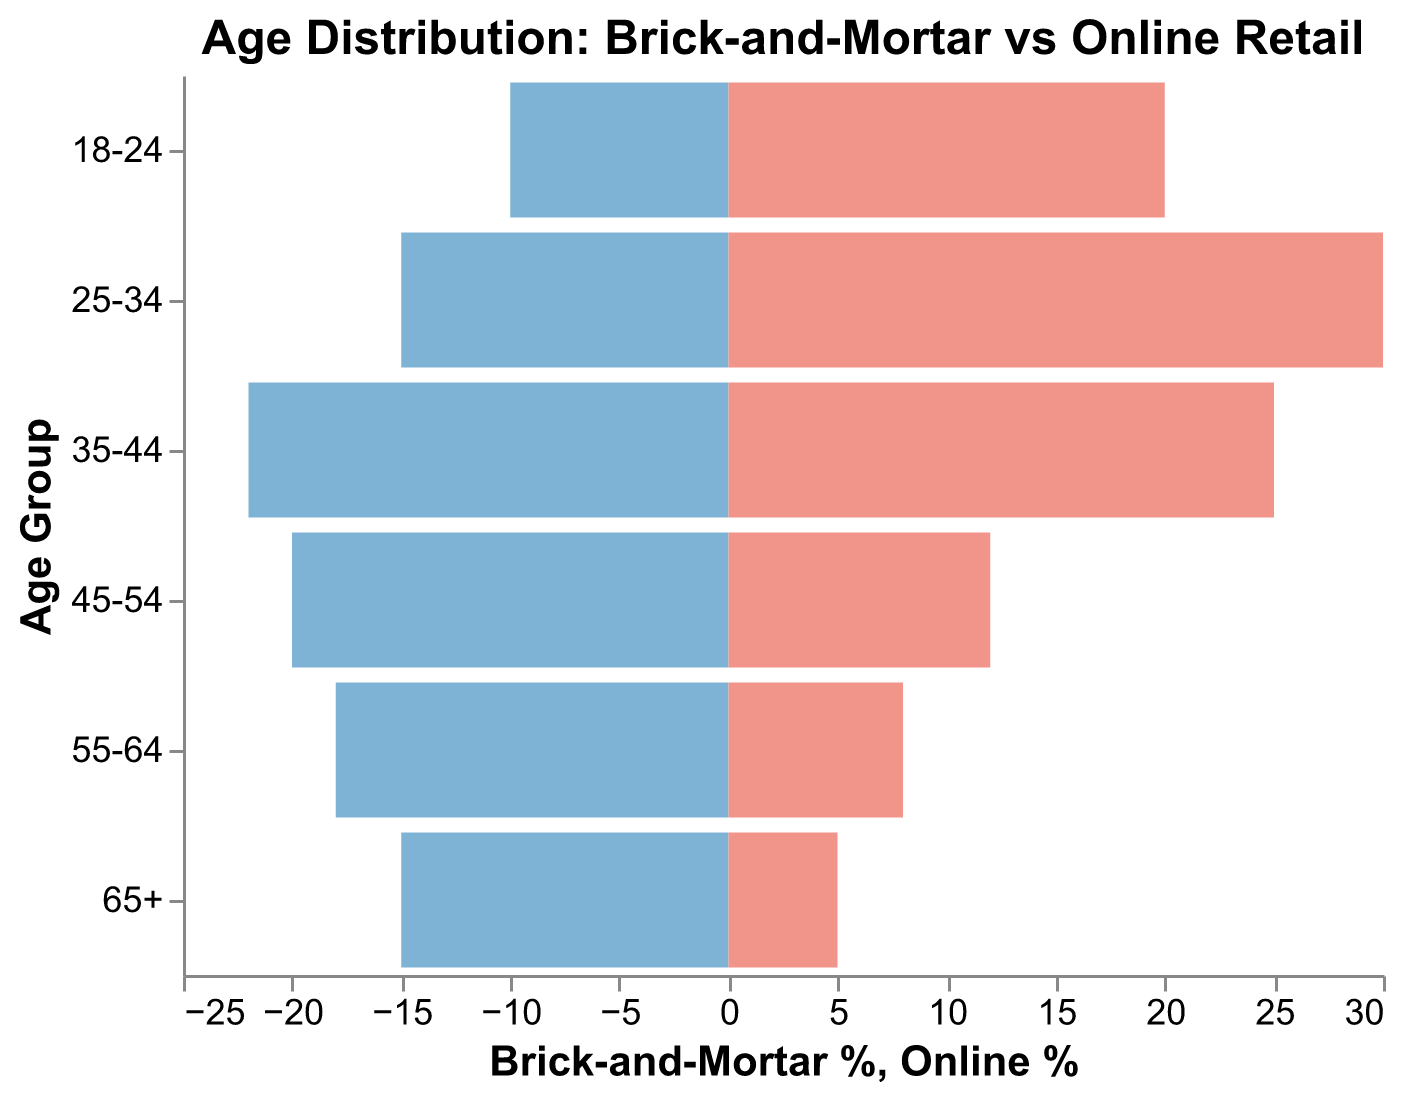Which age group has the highest percentage in brick-and-mortar stores? From the figure, look at the lengths of the bars representing each age group for brick-and-mortar stores. The longest bar represents the age group with the highest percentage, which is 35-44 at 22%.
Answer: 35-44 Which age group has the highest percentage in online stores? From the figure, identify the longest bar for online stores. The age group 25-34 has the highest percentage with a bar length representing 30%.
Answer: 25-34 What is the difference in the percentage of customers aged 18-24 between online and brick-and-mortar stores? For the age group 18-24, look at the percentages for brick-and-mortar (10%) and online (20%). Calculate the difference as 20% - 10%.
Answer: 10% Which age group shows a higher preference for online shopping compared to brick-and-mortar stores? Look for the group where the percentage in online stores is greater than in brick-and-mortar stores. Age groups 35-44, 25-34, and 18-24 show this pattern. The required group with the most prominent difference is 25-34 with 30% online vs 15% brick-and-mortar.
Answer: 25-34 Which age group is least represented in online stores? Find the shortest bar for online stores, which represents the age group with the lowest percentage. The age group 65+ has the smallest percentage at 5%.
Answer: 65+ What is the total percentage of customers from age groups 35-44 and 45-54 in brick-and-mortar stores? Identify the percentages for age groups 35-44 (22%) and 45-54 (20%) in brick-and-mortar stores. Sum these values to get 22% + 20%.
Answer: 42% By how much is the percentage of customers aged 55-64 higher in brick-and-mortar stores compared to online stores? For the age group 55-64, identify the percentages for brick-and-mortar (18%) and online (8%). Calculate the difference as 18% - 8%.
Answer: 10% Which age group has the closest percentage distribution between brick-and-mortar and online stores? Compare the percentages for each age group between the two store types. The age group 45-54 has the closest distribution with 20% in brick-and-mortar and 12% in online stores.
Answer: 45-54 What percentage of customers aged 65+ prefer brick-and-mortar stores over online stores? For the age group 65+, identify the percentages for brick-and-mortar (15%) and online (5%). Compare these values to determine the preference.
Answer: 15% 